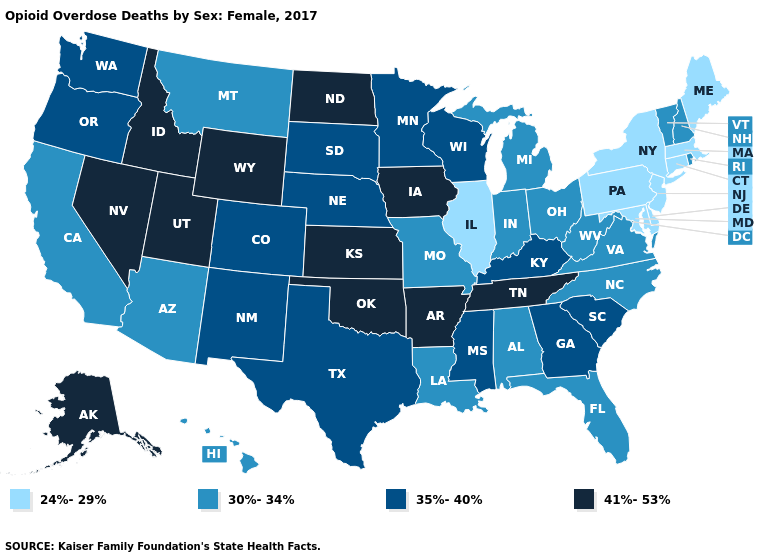What is the value of Illinois?
Write a very short answer. 24%-29%. Name the states that have a value in the range 30%-34%?
Quick response, please. Alabama, Arizona, California, Florida, Hawaii, Indiana, Louisiana, Michigan, Missouri, Montana, New Hampshire, North Carolina, Ohio, Rhode Island, Vermont, Virginia, West Virginia. What is the lowest value in states that border California?
Answer briefly. 30%-34%. Name the states that have a value in the range 30%-34%?
Short answer required. Alabama, Arizona, California, Florida, Hawaii, Indiana, Louisiana, Michigan, Missouri, Montana, New Hampshire, North Carolina, Ohio, Rhode Island, Vermont, Virginia, West Virginia. What is the highest value in the USA?
Quick response, please. 41%-53%. Which states have the lowest value in the USA?
Give a very brief answer. Connecticut, Delaware, Illinois, Maine, Maryland, Massachusetts, New Jersey, New York, Pennsylvania. Which states hav the highest value in the South?
Concise answer only. Arkansas, Oklahoma, Tennessee. Which states have the highest value in the USA?
Concise answer only. Alaska, Arkansas, Idaho, Iowa, Kansas, Nevada, North Dakota, Oklahoma, Tennessee, Utah, Wyoming. Does New Jersey have the lowest value in the USA?
Quick response, please. Yes. Name the states that have a value in the range 30%-34%?
Concise answer only. Alabama, Arizona, California, Florida, Hawaii, Indiana, Louisiana, Michigan, Missouri, Montana, New Hampshire, North Carolina, Ohio, Rhode Island, Vermont, Virginia, West Virginia. Does California have the lowest value in the West?
Quick response, please. Yes. Name the states that have a value in the range 24%-29%?
Be succinct. Connecticut, Delaware, Illinois, Maine, Maryland, Massachusetts, New Jersey, New York, Pennsylvania. Does Wyoming have a lower value than Kentucky?
Give a very brief answer. No. What is the highest value in the West ?
Quick response, please. 41%-53%. How many symbols are there in the legend?
Be succinct. 4. 